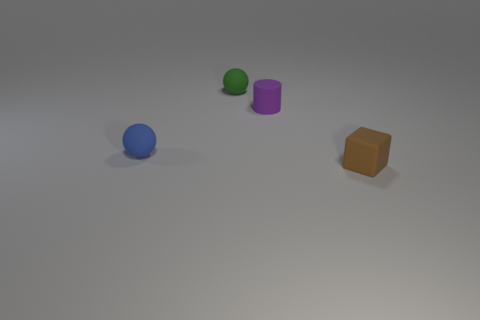Are there an equal number of tiny brown matte blocks that are left of the tiny brown cube and tiny blue objects that are behind the small blue matte sphere?
Offer a very short reply. Yes. There is a tiny matte ball behind the tiny rubber ball in front of the purple rubber cylinder; is there a blue object that is on the left side of it?
Keep it short and to the point. Yes. The matte sphere behind the small rubber thing that is on the left side of the tiny rubber ball behind the tiny purple rubber cylinder is what color?
Your answer should be very brief. Green. How many other small matte blocks are the same color as the rubber cube?
Your response must be concise. 0. How many tiny things are either yellow matte blocks or cylinders?
Offer a terse response. 1. Are there any other objects that have the same shape as the small blue matte thing?
Provide a succinct answer. Yes. Is the shape of the brown rubber thing the same as the tiny blue object?
Keep it short and to the point. No. There is a block that is to the right of the ball that is behind the small blue object; what color is it?
Your answer should be compact. Brown. There is a cylinder that is the same size as the blue rubber object; what color is it?
Make the answer very short. Purple. What number of metal things are tiny cylinders or small blocks?
Your answer should be very brief. 0. 